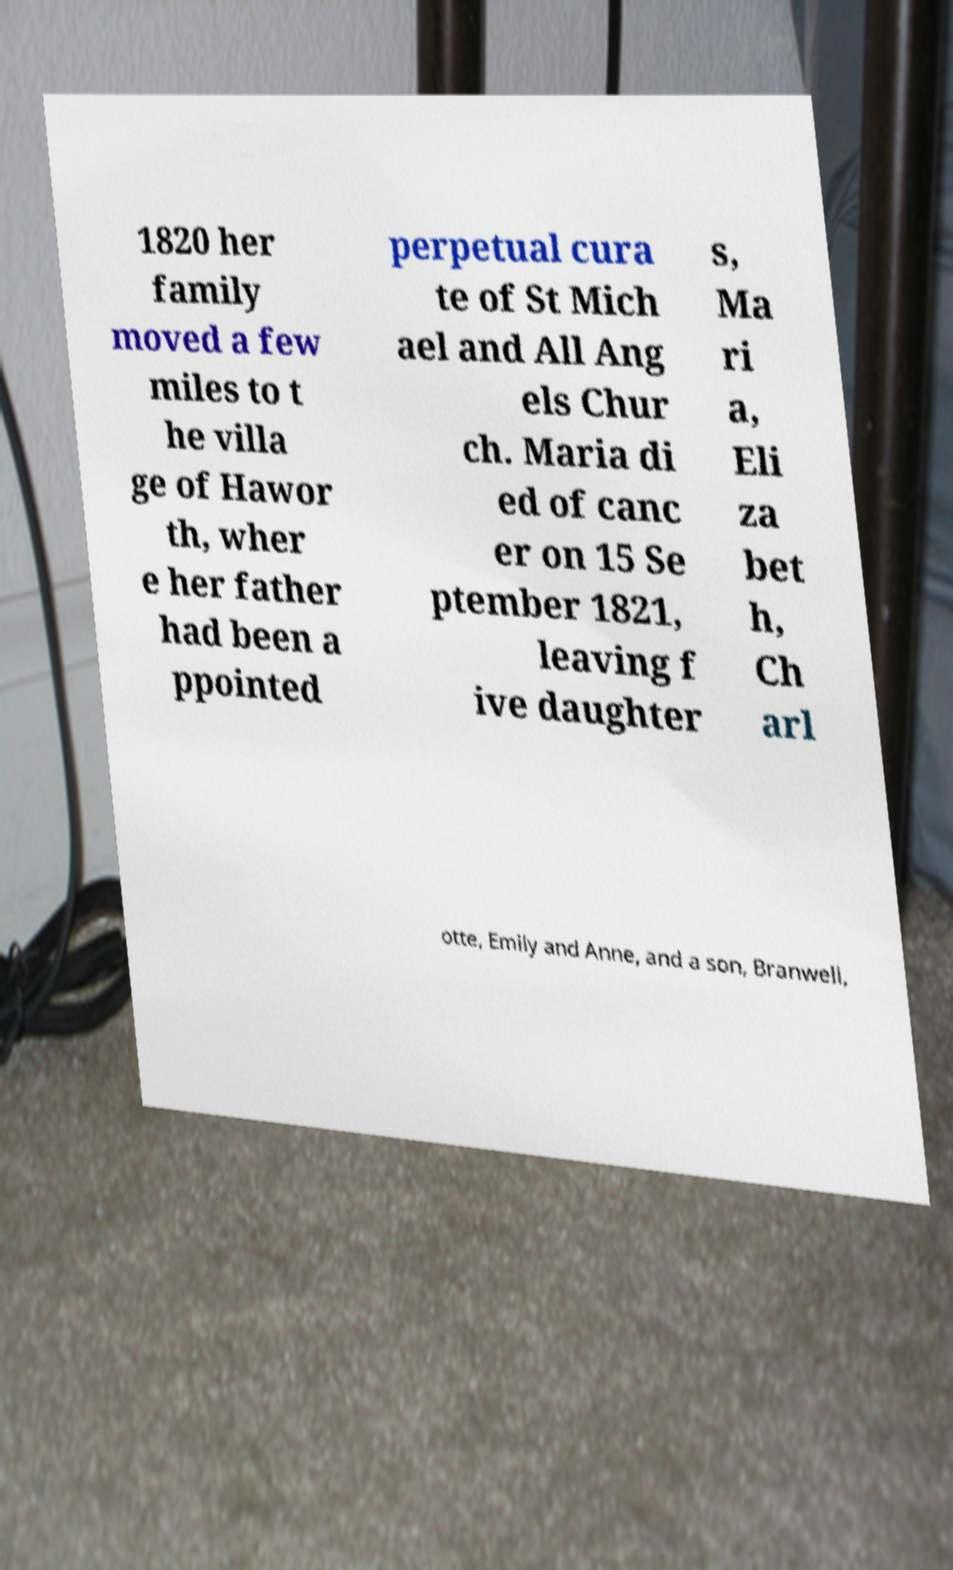Can you accurately transcribe the text from the provided image for me? 1820 her family moved a few miles to t he villa ge of Hawor th, wher e her father had been a ppointed perpetual cura te of St Mich ael and All Ang els Chur ch. Maria di ed of canc er on 15 Se ptember 1821, leaving f ive daughter s, Ma ri a, Eli za bet h, Ch arl otte, Emily and Anne, and a son, Branwell, 